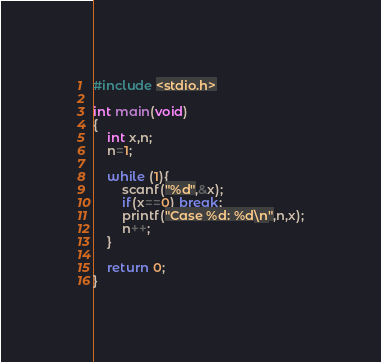<code> <loc_0><loc_0><loc_500><loc_500><_C_>#include <stdio.h>

int main(void)
{
	int x,n;
	n=1;
	
	while (1){
		scanf("%d",&x);
		if(x==0) break;
		printf("Case %d: %d\n",n,x);
		n++;
	}
	
	return 0;
}</code> 